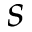Convert formula to latex. <formula><loc_0><loc_0><loc_500><loc_500>s</formula> 